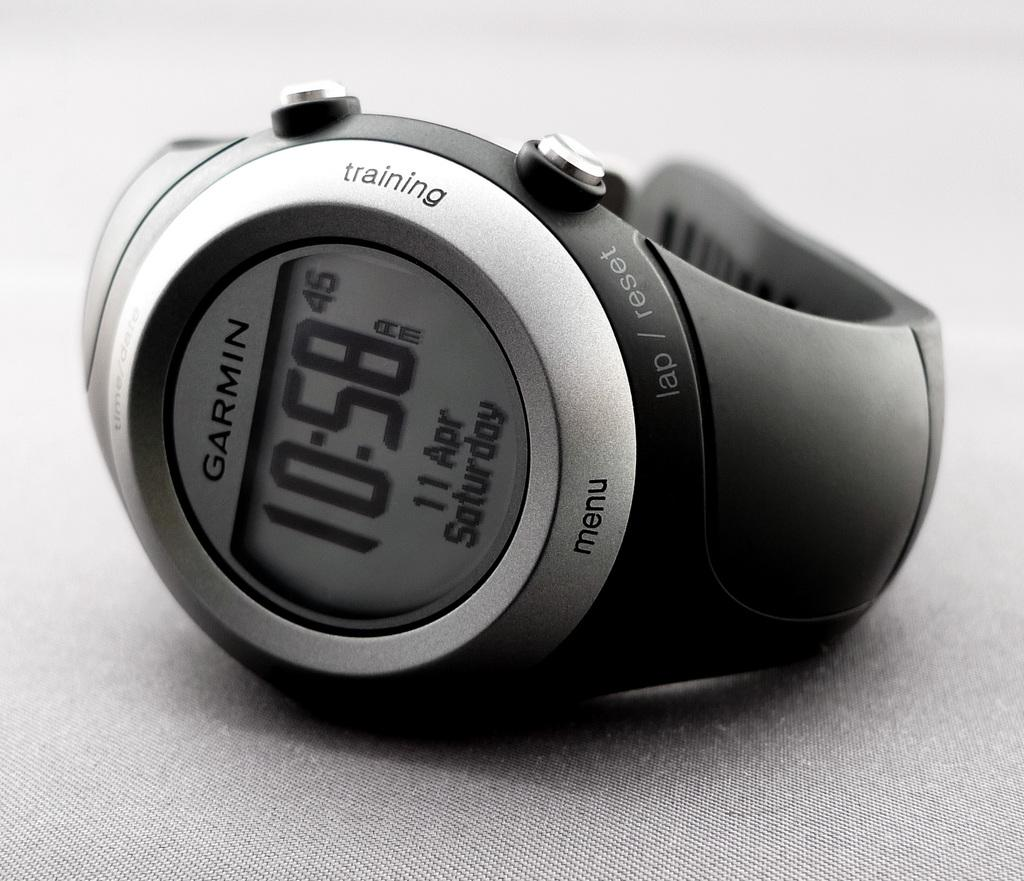<image>
Create a compact narrative representing the image presented. Black and silver wristwatch which says Garmin on it. 